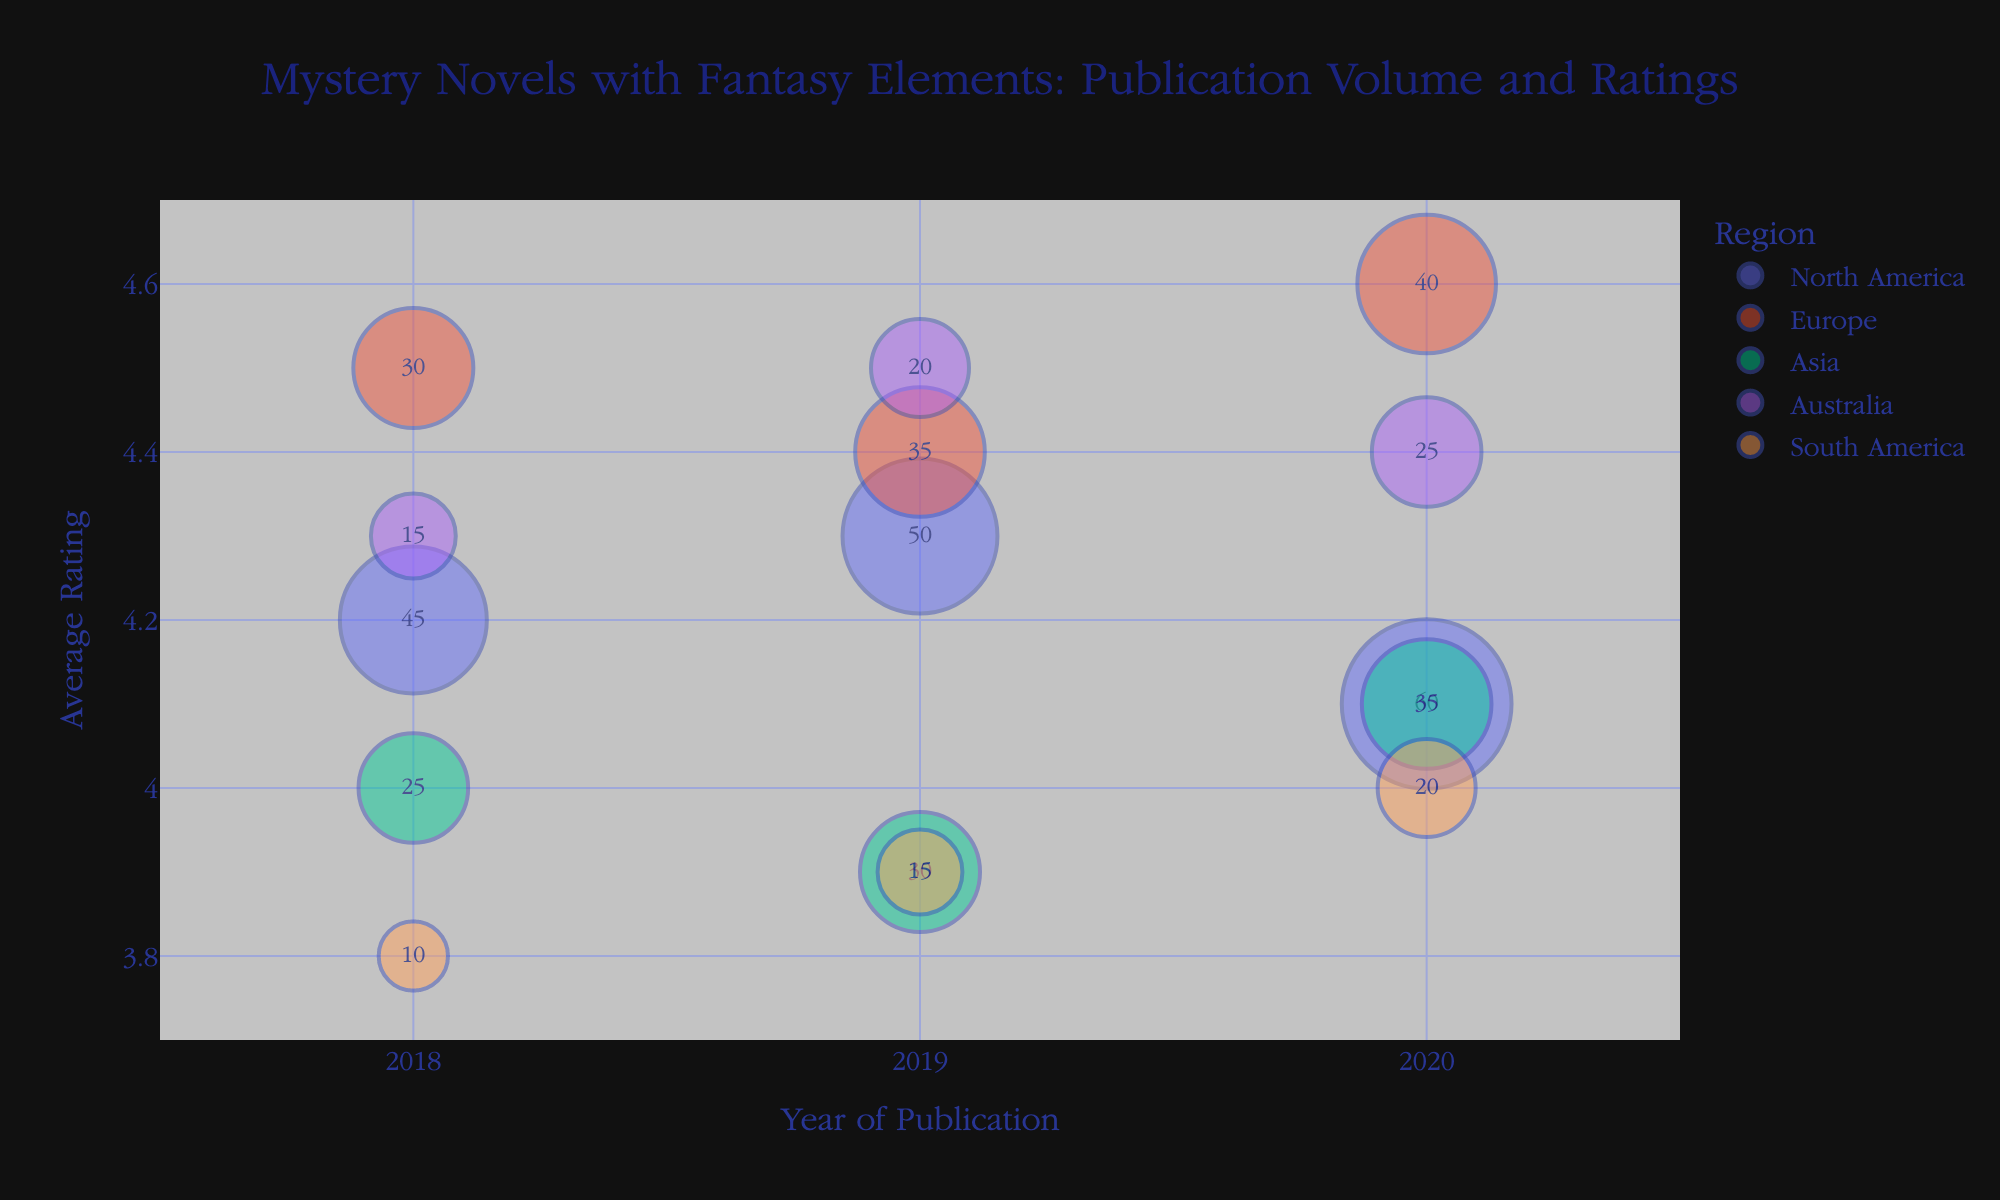What's the title of the chart? The chart's title is usually placed at the top-center and directly describes the subject of the visualization. The title in this chart is "Mystery Novels with Fantasy Elements: Publication Volume and Ratings"
Answer: Mystery Novels with Fantasy Elements: Publication Volume and Ratings What are the axis titles? The X-axis and Y-axis titles can be identified by looking at the labels beside each axis. They describe what the axes represent. The X-axis title is "Year of Publication" and the Y-axis title is "Average Rating".
Answer: Year of Publication, Average Rating How many regions are represented in the chart? The regions are differentiated by color and mentioned in the hover or text labels. By counting the unique regions, we can determine the number. There are five regions represented: North America, Europe, Asia, Australia, and South America.
Answer: Five Which region had the highest number of publications in 2020? By referring to the bubbles at the year 2020 on the X-axis and checking their sizes, we can identify the region with the largest bubble. North America had the largest bubble in 2020.
Answer: North America Was the average rating for mystery novels with fantasy elements higher in Europe or North America in 2019? By looking at the vertical positions of the bubbles for Europe and North America at the year 2019, the higher placed bubble on the Y-axis indicates a higher rating. Europe’s bubble is positioned higher than North America’s for 2019.
Answer: Europe What is the average rating for Australian publications in 2019? Hover over or look at the bubble for Australia in 2019 and check the Y-axis value for its vertical position. The average rating is positioned at 4.5.
Answer: 4.5 Which region shows a consistent increase in the number of publications from 2018 to 2020? By tracking the bubble sizes for each region over the years 2018 to 2020, the region with bubbles that consistently increase in size indicates a consistent increase in publications. All regions show an increase but North America, Europe, and Asia are prominent examples.
Answer: North America, Europe, Asia Compare the average ratings of mystery novels with fantasy elements in Asia and South America in 2018. Which region had a higher rating? Check the vertical positions of the bubbles for Asia and South America in 2018. The bubble positioned higher on the Y-axis has a higher rating. Asia had a higher rating than South America in 2018.
Answer: Asia Which region experienced the greatest increase in average rating from 2018 to 2020? Comparing the vertical displacement of bubbles from 2018 to 2020 for each region will identify the greatest increase. Europe experienced a significant increase from 4.5 to 4.6.
Answer: Europe How do the publication volumes and average ratings for mystery novels with fantasy elements in Asia compare between 2019 and 2020? Check the bubble sizes (publication volumes) and their Y-axis positions (average ratings) for Asia in both years. The number of publications increased from 30 to 35, and the average rating increased from 3.9 to 4.1.
Answer: Increased in both publication volume and average rating 